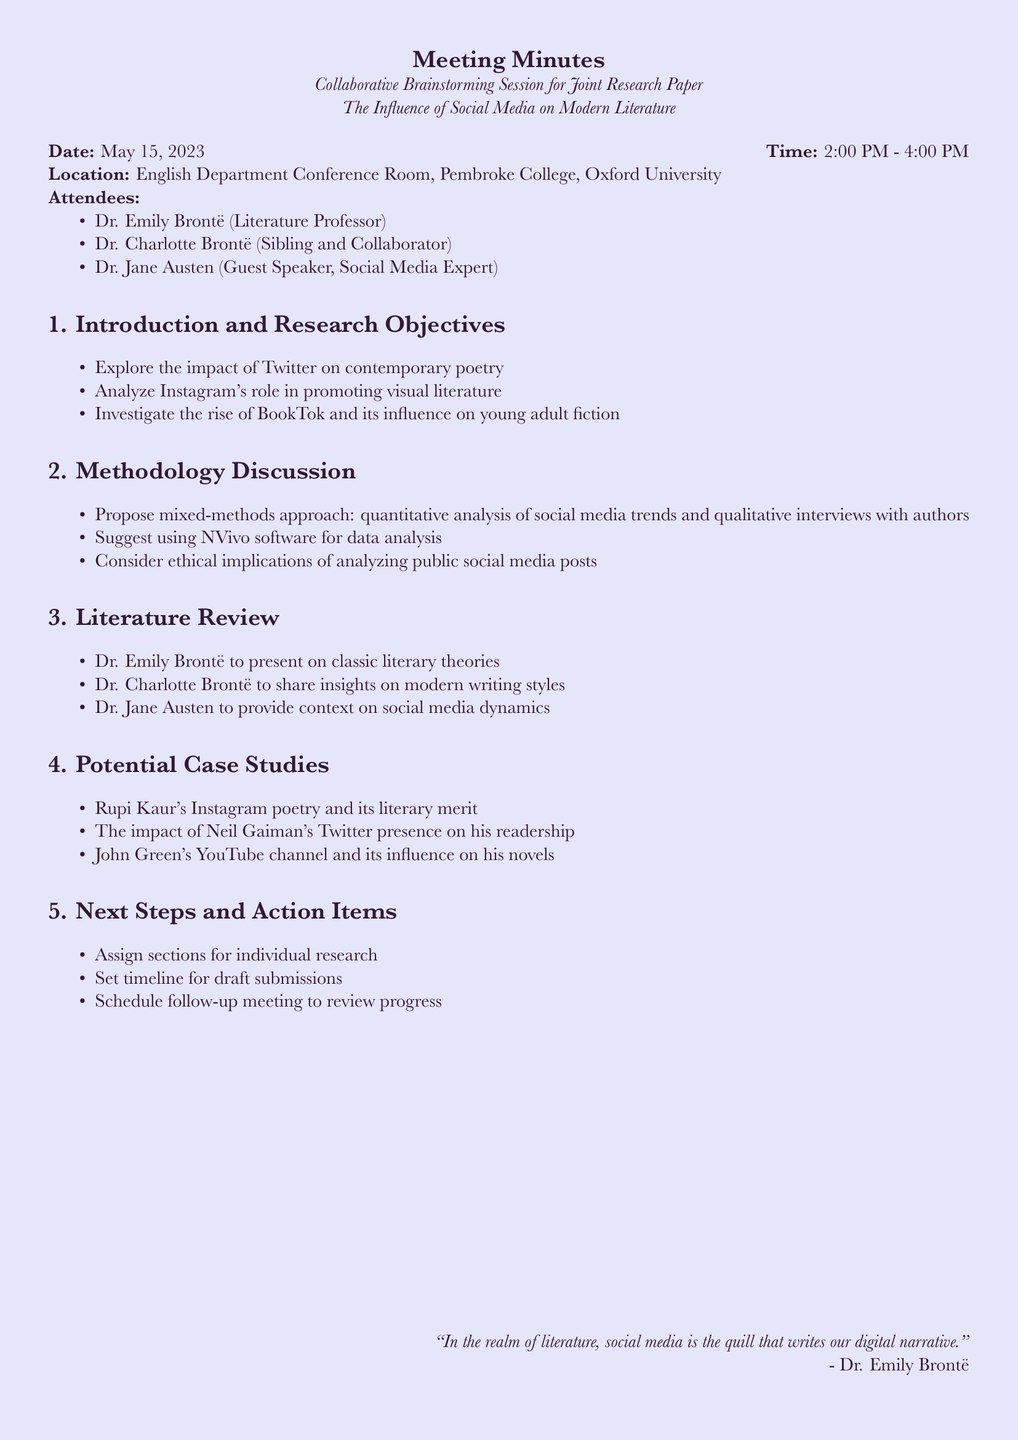What is the date of the meeting? The date of the meeting is listed in the document under meeting details.
Answer: May 15, 2023 What is the location of the meeting? The location is specified in the meeting details section.
Answer: English Department Conference Room, Pembroke College, Oxford University Who is the guest speaker at the meeting? The name of the guest speaker can be found in the attendees section of the document.
Answer: Dr. Jane Austen What is one of the research objectives discussed? The research objectives are listed in the introduction section and cover various impacts of social media.
Answer: Explore the impact of Twitter on contemporary poetry Which software is suggested for data analysis? The methodology discussion mentions a specific software to be used for data analysis.
Answer: NVivo What type of approach is proposed for the research? The methodology section outlines the fundamental approach to the research.
Answer: Mixed-methods approach Who will present on classic literary theories? This is outlined in the literature review section with mentions of who will present on specific topics.
Answer: Dr. Emily Brontë What is one of the potential case studies mentioned? The potential case studies are listed in their respective section and provide various examples.
Answer: Rupi Kaur's Instagram poetry and its literary merit What is one of the next steps discussed? The next steps and action items section elaborates on plans for further tasks.
Answer: Assign sections for individual research 